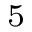Convert formula to latex. <formula><loc_0><loc_0><loc_500><loc_500>_ { 5 }</formula> 